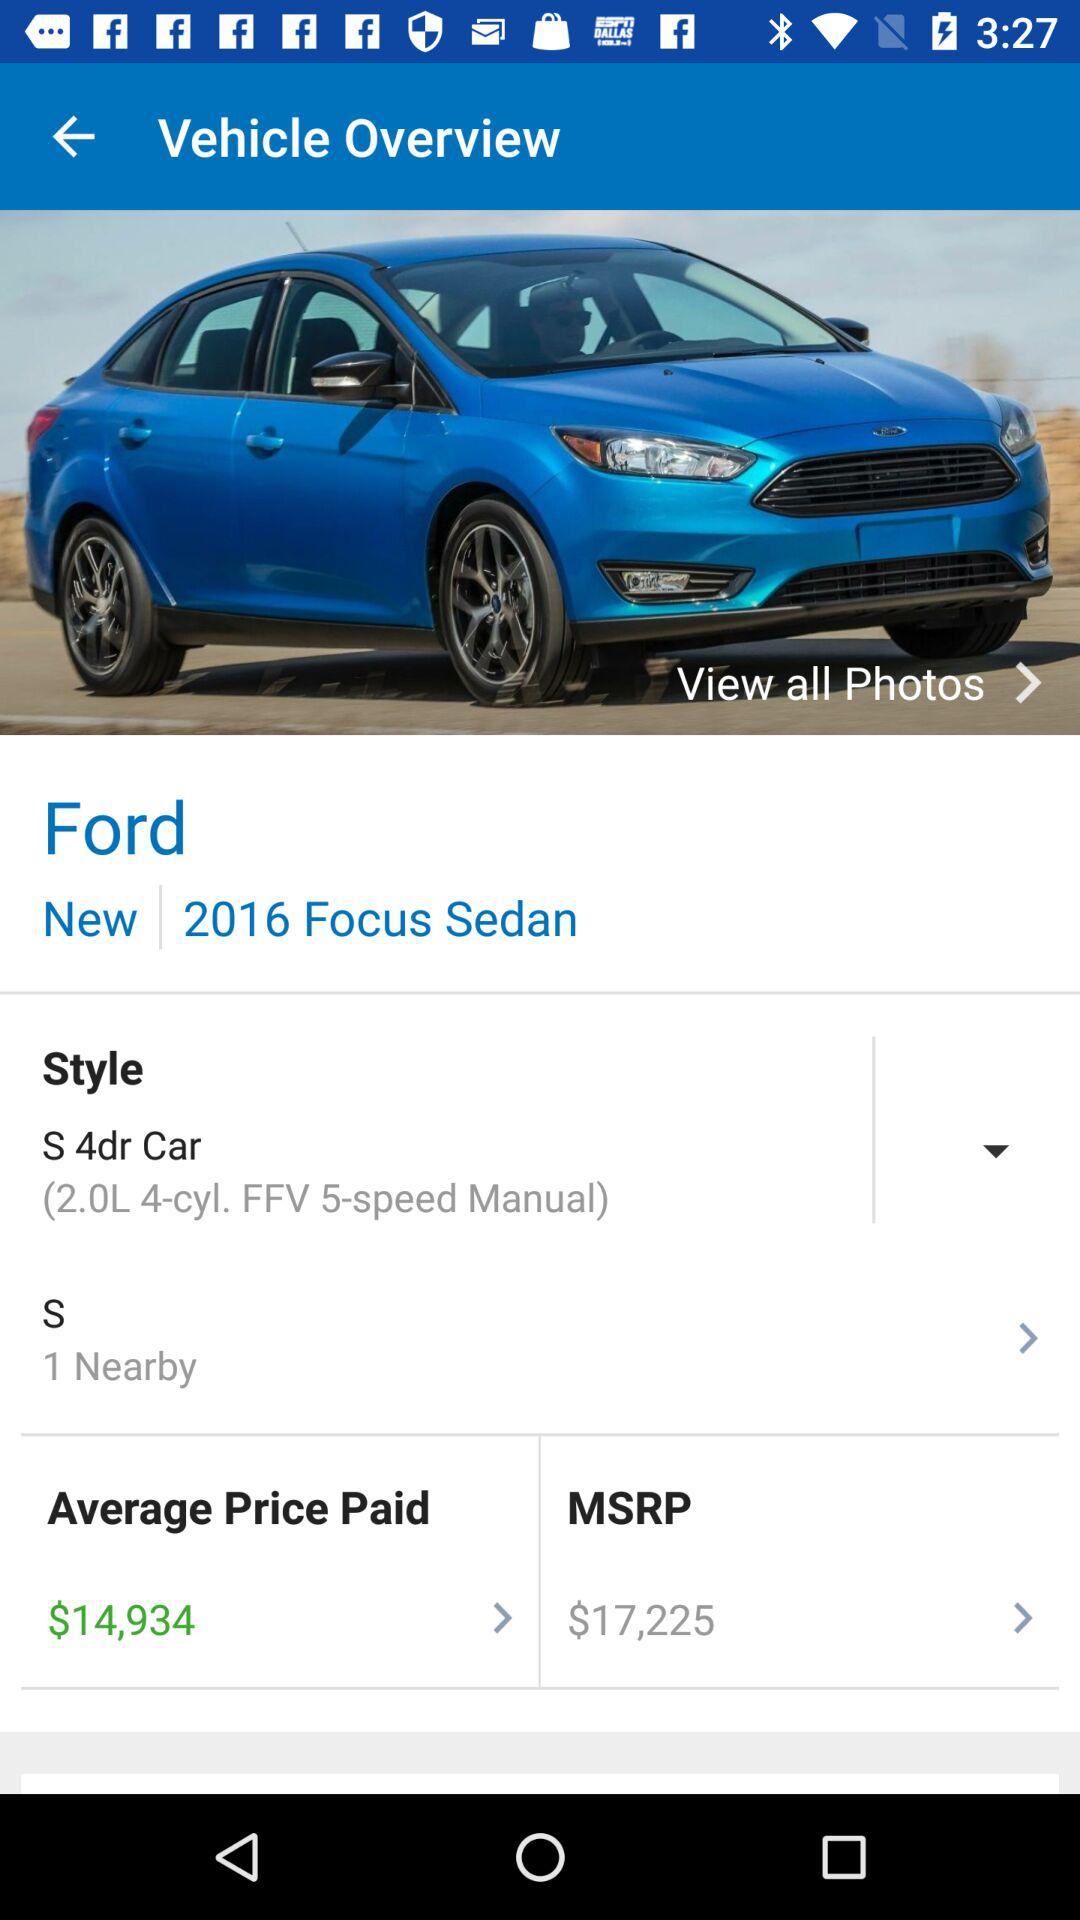How many nearby vehicles are there?
Answer the question using a single word or phrase. 1 